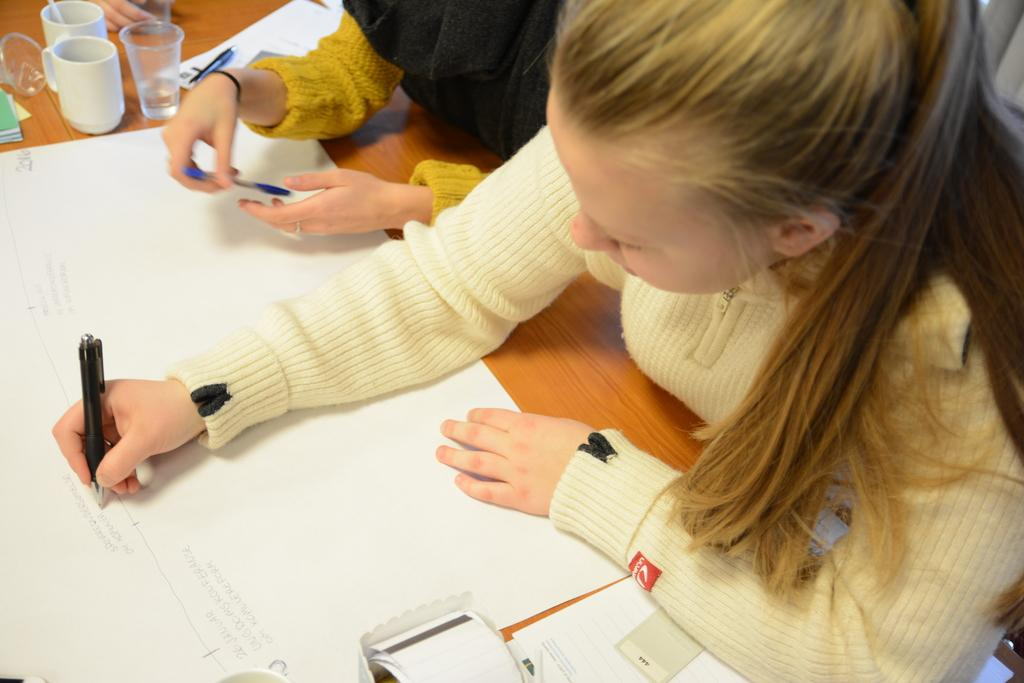How many kids are present in the image? There are two kids in the image. What are the kids doing in the image? The kids are sitting in front of a table and writing on a chart placed on the table. What can be seen around the chart on the table? There are cups and glasses around the chart on the table. What other items are visible on the table? There are other items visible on the table, but their specific nature is not mentioned in the provided facts. What type of cap is the apple wearing in the image? There is no apple or cap present in the image. 